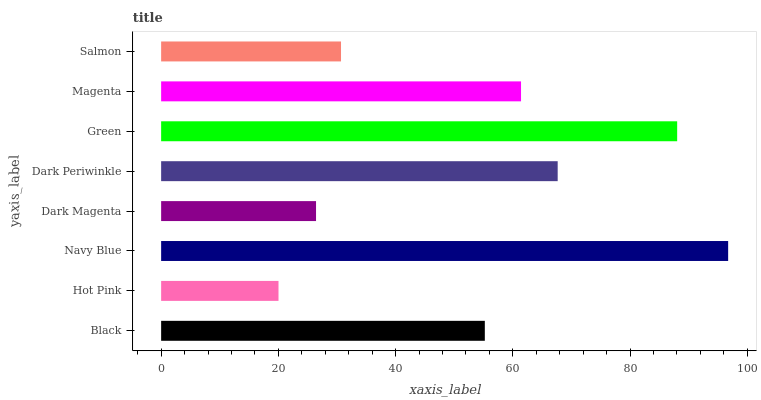Is Hot Pink the minimum?
Answer yes or no. Yes. Is Navy Blue the maximum?
Answer yes or no. Yes. Is Navy Blue the minimum?
Answer yes or no. No. Is Hot Pink the maximum?
Answer yes or no. No. Is Navy Blue greater than Hot Pink?
Answer yes or no. Yes. Is Hot Pink less than Navy Blue?
Answer yes or no. Yes. Is Hot Pink greater than Navy Blue?
Answer yes or no. No. Is Navy Blue less than Hot Pink?
Answer yes or no. No. Is Magenta the high median?
Answer yes or no. Yes. Is Black the low median?
Answer yes or no. Yes. Is Green the high median?
Answer yes or no. No. Is Hot Pink the low median?
Answer yes or no. No. 